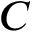Convert formula to latex. <formula><loc_0><loc_0><loc_500><loc_500>C</formula> 